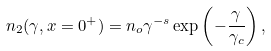Convert formula to latex. <formula><loc_0><loc_0><loc_500><loc_500>n _ { 2 } ( \gamma { , x = 0 ^ { + } } ) = n _ { o } \gamma ^ { - s } \exp \left ( - \frac { \gamma } { \gamma _ { c } } \right ) ,</formula> 